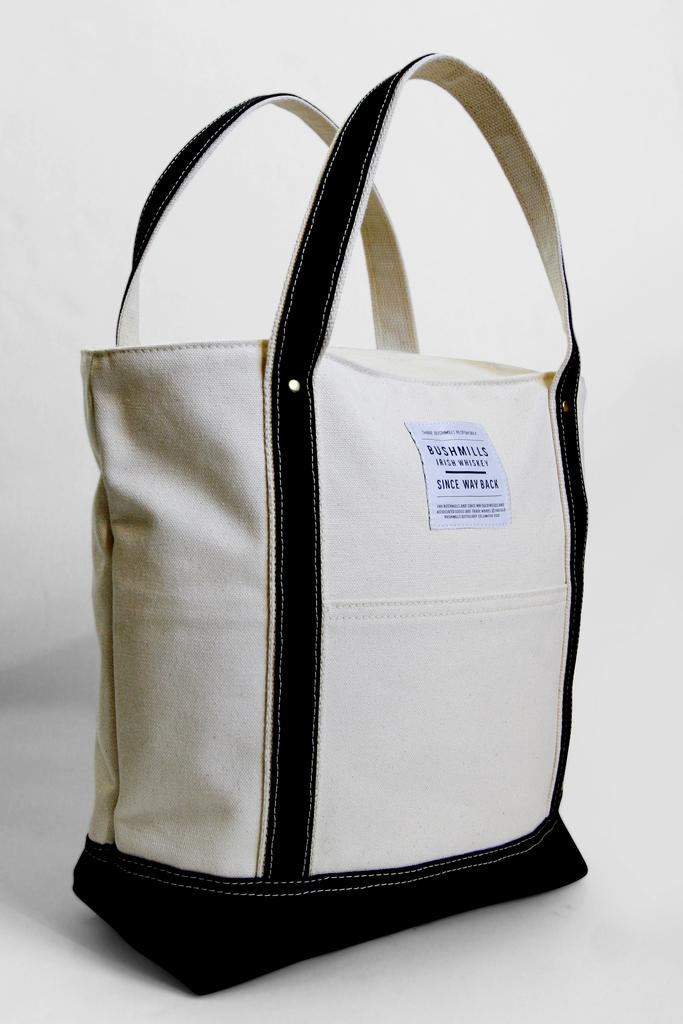What is the main subject of the image? The main subject of the image is a handbag. Can you describe the color scheme of the image? The image is black and white in color. What type of veil is draped over the elbow in the image? There is no veil or elbow present in the image; it only features a handbag. 